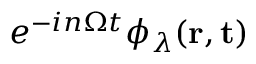Convert formula to latex. <formula><loc_0><loc_0><loc_500><loc_500>e ^ { - i n \Omega t } \phi _ { \lambda } ( r , t )</formula> 